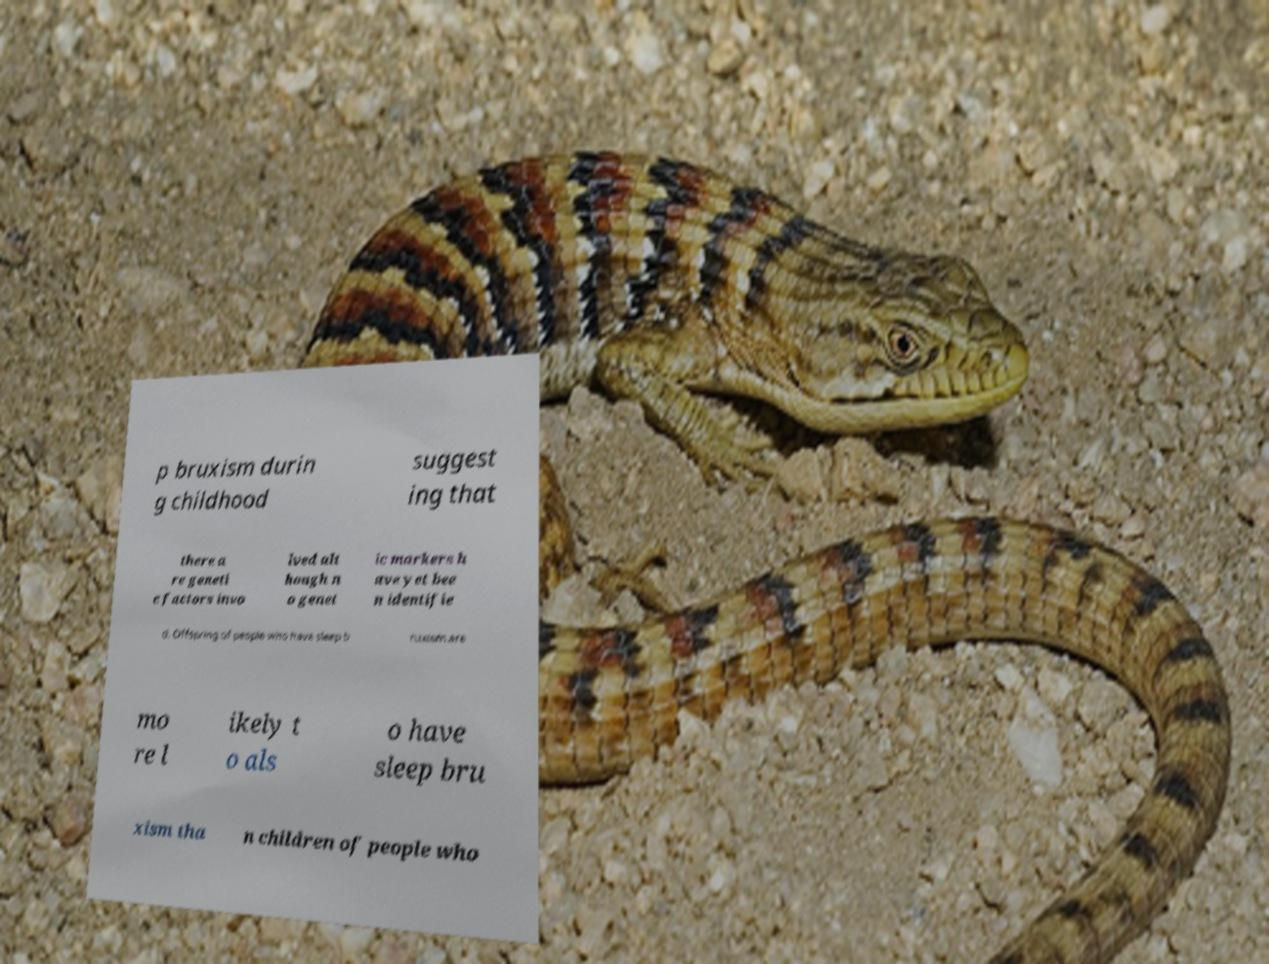There's text embedded in this image that I need extracted. Can you transcribe it verbatim? p bruxism durin g childhood suggest ing that there a re geneti c factors invo lved alt hough n o genet ic markers h ave yet bee n identifie d. Offspring of people who have sleep b ruxism are mo re l ikely t o als o have sleep bru xism tha n children of people who 